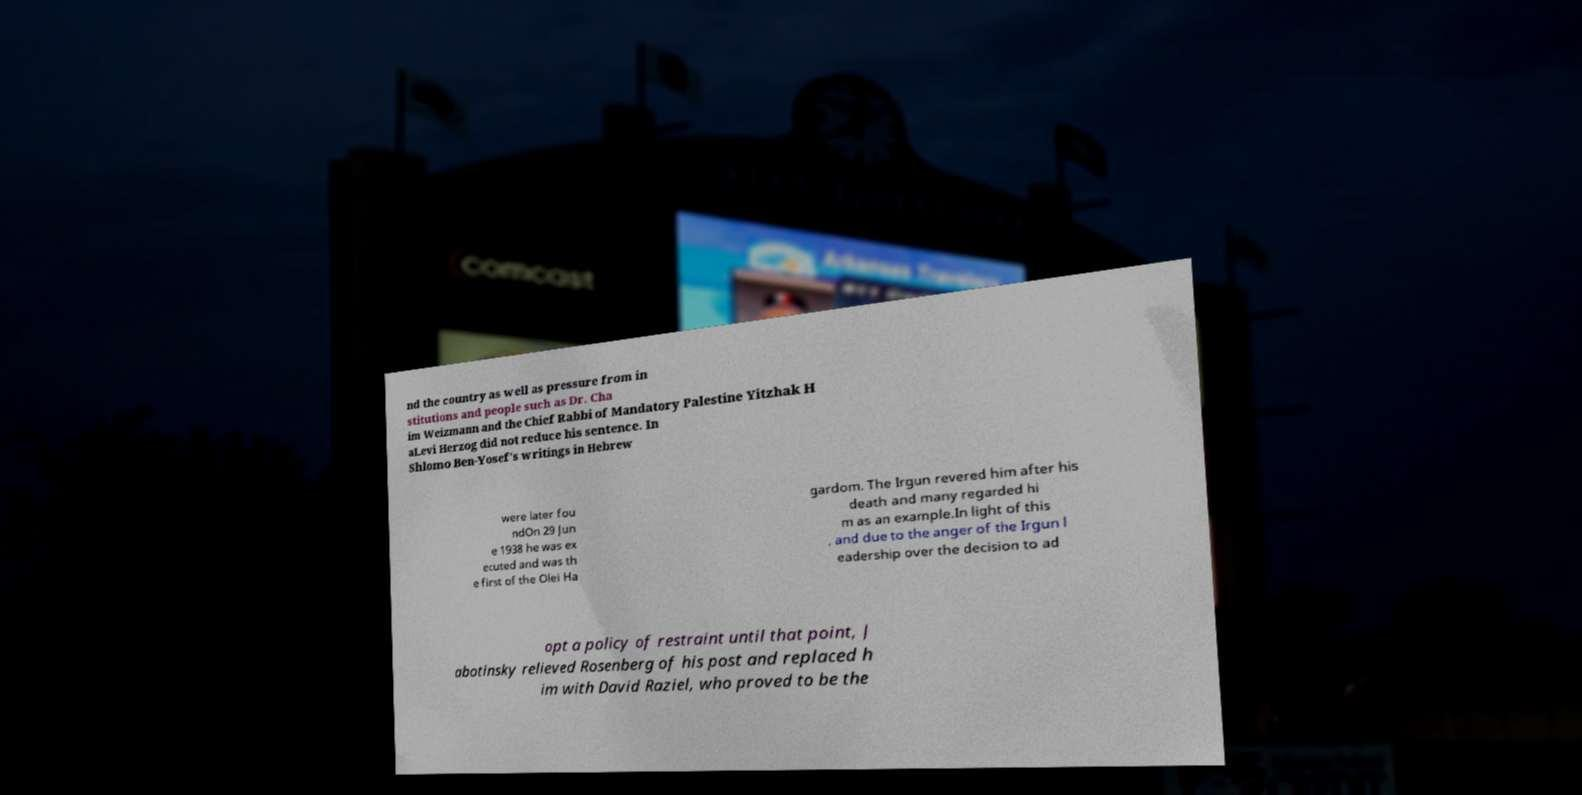For documentation purposes, I need the text within this image transcribed. Could you provide that? nd the country as well as pressure from in stitutions and people such as Dr. Cha im Weizmann and the Chief Rabbi of Mandatory Palestine Yitzhak H aLevi Herzog did not reduce his sentence. In Shlomo Ben-Yosef's writings in Hebrew were later fou ndOn 29 Jun e 1938 he was ex ecuted and was th e first of the Olei Ha gardom. The Irgun revered him after his death and many regarded hi m as an example.In light of this , and due to the anger of the Irgun l eadership over the decision to ad opt a policy of restraint until that point, J abotinsky relieved Rosenberg of his post and replaced h im with David Raziel, who proved to be the 